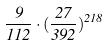<formula> <loc_0><loc_0><loc_500><loc_500>\frac { 9 } { 1 1 2 } \cdot ( \frac { 2 7 } { 3 9 2 } ) ^ { 2 1 8 }</formula> 